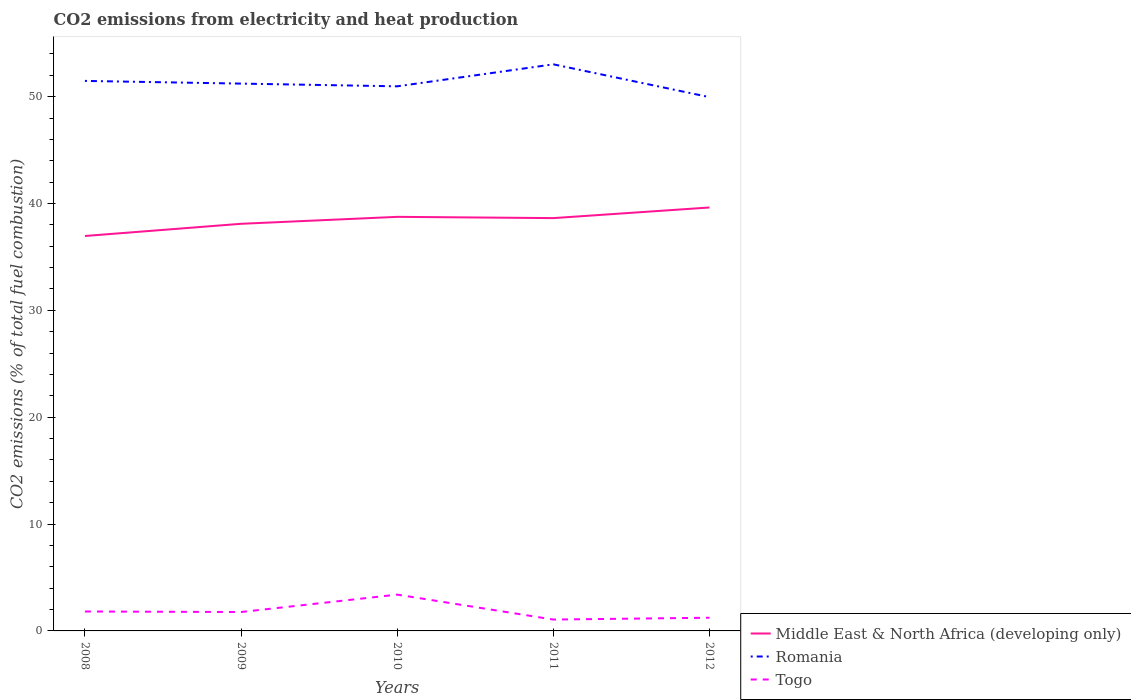Does the line corresponding to Romania intersect with the line corresponding to Togo?
Your answer should be very brief. No. Is the number of lines equal to the number of legend labels?
Keep it short and to the point. Yes. Across all years, what is the maximum amount of CO2 emitted in Romania?
Your response must be concise. 49.96. What is the total amount of CO2 emitted in Middle East & North Africa (developing only) in the graph?
Keep it short and to the point. -1.14. What is the difference between the highest and the second highest amount of CO2 emitted in Middle East & North Africa (developing only)?
Provide a short and direct response. 2.67. How many lines are there?
Make the answer very short. 3. Are the values on the major ticks of Y-axis written in scientific E-notation?
Ensure brevity in your answer.  No. What is the title of the graph?
Make the answer very short. CO2 emissions from electricity and heat production. Does "Small states" appear as one of the legend labels in the graph?
Your response must be concise. No. What is the label or title of the Y-axis?
Your answer should be compact. CO2 emissions (% of total fuel combustion). What is the CO2 emissions (% of total fuel combustion) in Middle East & North Africa (developing only) in 2008?
Your answer should be compact. 36.96. What is the CO2 emissions (% of total fuel combustion) in Romania in 2008?
Give a very brief answer. 51.47. What is the CO2 emissions (% of total fuel combustion) in Togo in 2008?
Provide a succinct answer. 1.82. What is the CO2 emissions (% of total fuel combustion) in Middle East & North Africa (developing only) in 2009?
Give a very brief answer. 38.1. What is the CO2 emissions (% of total fuel combustion) of Romania in 2009?
Ensure brevity in your answer.  51.22. What is the CO2 emissions (% of total fuel combustion) of Togo in 2009?
Give a very brief answer. 1.77. What is the CO2 emissions (% of total fuel combustion) in Middle East & North Africa (developing only) in 2010?
Your answer should be very brief. 38.75. What is the CO2 emissions (% of total fuel combustion) in Romania in 2010?
Offer a very short reply. 50.97. What is the CO2 emissions (% of total fuel combustion) of Togo in 2010?
Your answer should be very brief. 3.4. What is the CO2 emissions (% of total fuel combustion) of Middle East & North Africa (developing only) in 2011?
Provide a succinct answer. 38.63. What is the CO2 emissions (% of total fuel combustion) in Romania in 2011?
Give a very brief answer. 53.03. What is the CO2 emissions (% of total fuel combustion) of Togo in 2011?
Keep it short and to the point. 1.06. What is the CO2 emissions (% of total fuel combustion) of Middle East & North Africa (developing only) in 2012?
Offer a very short reply. 39.63. What is the CO2 emissions (% of total fuel combustion) of Romania in 2012?
Offer a terse response. 49.96. What is the CO2 emissions (% of total fuel combustion) of Togo in 2012?
Your response must be concise. 1.23. Across all years, what is the maximum CO2 emissions (% of total fuel combustion) in Middle East & North Africa (developing only)?
Provide a succinct answer. 39.63. Across all years, what is the maximum CO2 emissions (% of total fuel combustion) in Romania?
Give a very brief answer. 53.03. Across all years, what is the maximum CO2 emissions (% of total fuel combustion) of Togo?
Ensure brevity in your answer.  3.4. Across all years, what is the minimum CO2 emissions (% of total fuel combustion) in Middle East & North Africa (developing only)?
Provide a succinct answer. 36.96. Across all years, what is the minimum CO2 emissions (% of total fuel combustion) of Romania?
Your response must be concise. 49.96. Across all years, what is the minimum CO2 emissions (% of total fuel combustion) of Togo?
Keep it short and to the point. 1.06. What is the total CO2 emissions (% of total fuel combustion) of Middle East & North Africa (developing only) in the graph?
Your response must be concise. 192.08. What is the total CO2 emissions (% of total fuel combustion) in Romania in the graph?
Keep it short and to the point. 256.65. What is the total CO2 emissions (% of total fuel combustion) of Togo in the graph?
Keep it short and to the point. 9.28. What is the difference between the CO2 emissions (% of total fuel combustion) in Middle East & North Africa (developing only) in 2008 and that in 2009?
Keep it short and to the point. -1.14. What is the difference between the CO2 emissions (% of total fuel combustion) in Romania in 2008 and that in 2009?
Give a very brief answer. 0.25. What is the difference between the CO2 emissions (% of total fuel combustion) in Togo in 2008 and that in 2009?
Keep it short and to the point. 0.05. What is the difference between the CO2 emissions (% of total fuel combustion) of Middle East & North Africa (developing only) in 2008 and that in 2010?
Your answer should be compact. -1.79. What is the difference between the CO2 emissions (% of total fuel combustion) in Romania in 2008 and that in 2010?
Make the answer very short. 0.51. What is the difference between the CO2 emissions (% of total fuel combustion) of Togo in 2008 and that in 2010?
Your answer should be very brief. -1.58. What is the difference between the CO2 emissions (% of total fuel combustion) of Middle East & North Africa (developing only) in 2008 and that in 2011?
Keep it short and to the point. -1.67. What is the difference between the CO2 emissions (% of total fuel combustion) in Romania in 2008 and that in 2011?
Keep it short and to the point. -1.55. What is the difference between the CO2 emissions (% of total fuel combustion) in Togo in 2008 and that in 2011?
Give a very brief answer. 0.75. What is the difference between the CO2 emissions (% of total fuel combustion) in Middle East & North Africa (developing only) in 2008 and that in 2012?
Make the answer very short. -2.67. What is the difference between the CO2 emissions (% of total fuel combustion) of Romania in 2008 and that in 2012?
Offer a very short reply. 1.52. What is the difference between the CO2 emissions (% of total fuel combustion) of Togo in 2008 and that in 2012?
Ensure brevity in your answer.  0.58. What is the difference between the CO2 emissions (% of total fuel combustion) of Middle East & North Africa (developing only) in 2009 and that in 2010?
Your response must be concise. -0.65. What is the difference between the CO2 emissions (% of total fuel combustion) in Romania in 2009 and that in 2010?
Offer a terse response. 0.25. What is the difference between the CO2 emissions (% of total fuel combustion) in Togo in 2009 and that in 2010?
Offer a very short reply. -1.63. What is the difference between the CO2 emissions (% of total fuel combustion) in Middle East & North Africa (developing only) in 2009 and that in 2011?
Ensure brevity in your answer.  -0.53. What is the difference between the CO2 emissions (% of total fuel combustion) of Romania in 2009 and that in 2011?
Keep it short and to the point. -1.8. What is the difference between the CO2 emissions (% of total fuel combustion) of Togo in 2009 and that in 2011?
Make the answer very short. 0.71. What is the difference between the CO2 emissions (% of total fuel combustion) in Middle East & North Africa (developing only) in 2009 and that in 2012?
Offer a terse response. -1.53. What is the difference between the CO2 emissions (% of total fuel combustion) in Romania in 2009 and that in 2012?
Provide a succinct answer. 1.27. What is the difference between the CO2 emissions (% of total fuel combustion) in Togo in 2009 and that in 2012?
Provide a short and direct response. 0.54. What is the difference between the CO2 emissions (% of total fuel combustion) of Middle East & North Africa (developing only) in 2010 and that in 2011?
Offer a very short reply. 0.12. What is the difference between the CO2 emissions (% of total fuel combustion) in Romania in 2010 and that in 2011?
Make the answer very short. -2.06. What is the difference between the CO2 emissions (% of total fuel combustion) of Togo in 2010 and that in 2011?
Keep it short and to the point. 2.33. What is the difference between the CO2 emissions (% of total fuel combustion) in Middle East & North Africa (developing only) in 2010 and that in 2012?
Your response must be concise. -0.88. What is the difference between the CO2 emissions (% of total fuel combustion) in Romania in 2010 and that in 2012?
Offer a terse response. 1.01. What is the difference between the CO2 emissions (% of total fuel combustion) of Togo in 2010 and that in 2012?
Provide a succinct answer. 2.16. What is the difference between the CO2 emissions (% of total fuel combustion) in Middle East & North Africa (developing only) in 2011 and that in 2012?
Keep it short and to the point. -0.99. What is the difference between the CO2 emissions (% of total fuel combustion) of Romania in 2011 and that in 2012?
Offer a very short reply. 3.07. What is the difference between the CO2 emissions (% of total fuel combustion) of Togo in 2011 and that in 2012?
Your answer should be compact. -0.17. What is the difference between the CO2 emissions (% of total fuel combustion) in Middle East & North Africa (developing only) in 2008 and the CO2 emissions (% of total fuel combustion) in Romania in 2009?
Ensure brevity in your answer.  -14.26. What is the difference between the CO2 emissions (% of total fuel combustion) of Middle East & North Africa (developing only) in 2008 and the CO2 emissions (% of total fuel combustion) of Togo in 2009?
Your answer should be compact. 35.19. What is the difference between the CO2 emissions (% of total fuel combustion) in Romania in 2008 and the CO2 emissions (% of total fuel combustion) in Togo in 2009?
Your answer should be compact. 49.7. What is the difference between the CO2 emissions (% of total fuel combustion) in Middle East & North Africa (developing only) in 2008 and the CO2 emissions (% of total fuel combustion) in Romania in 2010?
Your response must be concise. -14.01. What is the difference between the CO2 emissions (% of total fuel combustion) of Middle East & North Africa (developing only) in 2008 and the CO2 emissions (% of total fuel combustion) of Togo in 2010?
Your answer should be compact. 33.56. What is the difference between the CO2 emissions (% of total fuel combustion) in Romania in 2008 and the CO2 emissions (% of total fuel combustion) in Togo in 2010?
Keep it short and to the point. 48.08. What is the difference between the CO2 emissions (% of total fuel combustion) of Middle East & North Africa (developing only) in 2008 and the CO2 emissions (% of total fuel combustion) of Romania in 2011?
Your response must be concise. -16.06. What is the difference between the CO2 emissions (% of total fuel combustion) in Middle East & North Africa (developing only) in 2008 and the CO2 emissions (% of total fuel combustion) in Togo in 2011?
Provide a succinct answer. 35.9. What is the difference between the CO2 emissions (% of total fuel combustion) in Romania in 2008 and the CO2 emissions (% of total fuel combustion) in Togo in 2011?
Your answer should be very brief. 50.41. What is the difference between the CO2 emissions (% of total fuel combustion) in Middle East & North Africa (developing only) in 2008 and the CO2 emissions (% of total fuel combustion) in Romania in 2012?
Offer a very short reply. -12.99. What is the difference between the CO2 emissions (% of total fuel combustion) in Middle East & North Africa (developing only) in 2008 and the CO2 emissions (% of total fuel combustion) in Togo in 2012?
Your response must be concise. 35.73. What is the difference between the CO2 emissions (% of total fuel combustion) of Romania in 2008 and the CO2 emissions (% of total fuel combustion) of Togo in 2012?
Give a very brief answer. 50.24. What is the difference between the CO2 emissions (% of total fuel combustion) of Middle East & North Africa (developing only) in 2009 and the CO2 emissions (% of total fuel combustion) of Romania in 2010?
Provide a succinct answer. -12.87. What is the difference between the CO2 emissions (% of total fuel combustion) of Middle East & North Africa (developing only) in 2009 and the CO2 emissions (% of total fuel combustion) of Togo in 2010?
Provide a short and direct response. 34.7. What is the difference between the CO2 emissions (% of total fuel combustion) in Romania in 2009 and the CO2 emissions (% of total fuel combustion) in Togo in 2010?
Your response must be concise. 47.82. What is the difference between the CO2 emissions (% of total fuel combustion) in Middle East & North Africa (developing only) in 2009 and the CO2 emissions (% of total fuel combustion) in Romania in 2011?
Provide a short and direct response. -14.92. What is the difference between the CO2 emissions (% of total fuel combustion) of Middle East & North Africa (developing only) in 2009 and the CO2 emissions (% of total fuel combustion) of Togo in 2011?
Make the answer very short. 37.04. What is the difference between the CO2 emissions (% of total fuel combustion) of Romania in 2009 and the CO2 emissions (% of total fuel combustion) of Togo in 2011?
Make the answer very short. 50.16. What is the difference between the CO2 emissions (% of total fuel combustion) in Middle East & North Africa (developing only) in 2009 and the CO2 emissions (% of total fuel combustion) in Romania in 2012?
Provide a succinct answer. -11.85. What is the difference between the CO2 emissions (% of total fuel combustion) in Middle East & North Africa (developing only) in 2009 and the CO2 emissions (% of total fuel combustion) in Togo in 2012?
Make the answer very short. 36.87. What is the difference between the CO2 emissions (% of total fuel combustion) in Romania in 2009 and the CO2 emissions (% of total fuel combustion) in Togo in 2012?
Offer a terse response. 49.99. What is the difference between the CO2 emissions (% of total fuel combustion) in Middle East & North Africa (developing only) in 2010 and the CO2 emissions (% of total fuel combustion) in Romania in 2011?
Provide a short and direct response. -14.27. What is the difference between the CO2 emissions (% of total fuel combustion) of Middle East & North Africa (developing only) in 2010 and the CO2 emissions (% of total fuel combustion) of Togo in 2011?
Keep it short and to the point. 37.69. What is the difference between the CO2 emissions (% of total fuel combustion) in Romania in 2010 and the CO2 emissions (% of total fuel combustion) in Togo in 2011?
Make the answer very short. 49.9. What is the difference between the CO2 emissions (% of total fuel combustion) of Middle East & North Africa (developing only) in 2010 and the CO2 emissions (% of total fuel combustion) of Romania in 2012?
Ensure brevity in your answer.  -11.2. What is the difference between the CO2 emissions (% of total fuel combustion) in Middle East & North Africa (developing only) in 2010 and the CO2 emissions (% of total fuel combustion) in Togo in 2012?
Your answer should be compact. 37.52. What is the difference between the CO2 emissions (% of total fuel combustion) of Romania in 2010 and the CO2 emissions (% of total fuel combustion) of Togo in 2012?
Offer a very short reply. 49.73. What is the difference between the CO2 emissions (% of total fuel combustion) of Middle East & North Africa (developing only) in 2011 and the CO2 emissions (% of total fuel combustion) of Romania in 2012?
Ensure brevity in your answer.  -11.32. What is the difference between the CO2 emissions (% of total fuel combustion) of Middle East & North Africa (developing only) in 2011 and the CO2 emissions (% of total fuel combustion) of Togo in 2012?
Your response must be concise. 37.4. What is the difference between the CO2 emissions (% of total fuel combustion) in Romania in 2011 and the CO2 emissions (% of total fuel combustion) in Togo in 2012?
Your answer should be very brief. 51.79. What is the average CO2 emissions (% of total fuel combustion) in Middle East & North Africa (developing only) per year?
Make the answer very short. 38.42. What is the average CO2 emissions (% of total fuel combustion) in Romania per year?
Offer a very short reply. 51.33. What is the average CO2 emissions (% of total fuel combustion) in Togo per year?
Make the answer very short. 1.86. In the year 2008, what is the difference between the CO2 emissions (% of total fuel combustion) in Middle East & North Africa (developing only) and CO2 emissions (% of total fuel combustion) in Romania?
Your answer should be compact. -14.51. In the year 2008, what is the difference between the CO2 emissions (% of total fuel combustion) of Middle East & North Africa (developing only) and CO2 emissions (% of total fuel combustion) of Togo?
Keep it short and to the point. 35.14. In the year 2008, what is the difference between the CO2 emissions (% of total fuel combustion) in Romania and CO2 emissions (% of total fuel combustion) in Togo?
Provide a succinct answer. 49.66. In the year 2009, what is the difference between the CO2 emissions (% of total fuel combustion) of Middle East & North Africa (developing only) and CO2 emissions (% of total fuel combustion) of Romania?
Offer a very short reply. -13.12. In the year 2009, what is the difference between the CO2 emissions (% of total fuel combustion) in Middle East & North Africa (developing only) and CO2 emissions (% of total fuel combustion) in Togo?
Offer a very short reply. 36.33. In the year 2009, what is the difference between the CO2 emissions (% of total fuel combustion) in Romania and CO2 emissions (% of total fuel combustion) in Togo?
Offer a very short reply. 49.45. In the year 2010, what is the difference between the CO2 emissions (% of total fuel combustion) of Middle East & North Africa (developing only) and CO2 emissions (% of total fuel combustion) of Romania?
Provide a short and direct response. -12.22. In the year 2010, what is the difference between the CO2 emissions (% of total fuel combustion) of Middle East & North Africa (developing only) and CO2 emissions (% of total fuel combustion) of Togo?
Provide a succinct answer. 35.35. In the year 2010, what is the difference between the CO2 emissions (% of total fuel combustion) of Romania and CO2 emissions (% of total fuel combustion) of Togo?
Offer a very short reply. 47.57. In the year 2011, what is the difference between the CO2 emissions (% of total fuel combustion) of Middle East & North Africa (developing only) and CO2 emissions (% of total fuel combustion) of Romania?
Your answer should be compact. -14.39. In the year 2011, what is the difference between the CO2 emissions (% of total fuel combustion) of Middle East & North Africa (developing only) and CO2 emissions (% of total fuel combustion) of Togo?
Provide a short and direct response. 37.57. In the year 2011, what is the difference between the CO2 emissions (% of total fuel combustion) of Romania and CO2 emissions (% of total fuel combustion) of Togo?
Your response must be concise. 51.96. In the year 2012, what is the difference between the CO2 emissions (% of total fuel combustion) of Middle East & North Africa (developing only) and CO2 emissions (% of total fuel combustion) of Romania?
Provide a short and direct response. -10.33. In the year 2012, what is the difference between the CO2 emissions (% of total fuel combustion) of Middle East & North Africa (developing only) and CO2 emissions (% of total fuel combustion) of Togo?
Your response must be concise. 38.39. In the year 2012, what is the difference between the CO2 emissions (% of total fuel combustion) in Romania and CO2 emissions (% of total fuel combustion) in Togo?
Make the answer very short. 48.72. What is the ratio of the CO2 emissions (% of total fuel combustion) of Middle East & North Africa (developing only) in 2008 to that in 2009?
Offer a very short reply. 0.97. What is the ratio of the CO2 emissions (% of total fuel combustion) in Romania in 2008 to that in 2009?
Provide a succinct answer. 1. What is the ratio of the CO2 emissions (% of total fuel combustion) of Togo in 2008 to that in 2009?
Provide a short and direct response. 1.03. What is the ratio of the CO2 emissions (% of total fuel combustion) in Middle East & North Africa (developing only) in 2008 to that in 2010?
Give a very brief answer. 0.95. What is the ratio of the CO2 emissions (% of total fuel combustion) of Romania in 2008 to that in 2010?
Your answer should be compact. 1.01. What is the ratio of the CO2 emissions (% of total fuel combustion) in Togo in 2008 to that in 2010?
Your answer should be very brief. 0.54. What is the ratio of the CO2 emissions (% of total fuel combustion) of Middle East & North Africa (developing only) in 2008 to that in 2011?
Give a very brief answer. 0.96. What is the ratio of the CO2 emissions (% of total fuel combustion) in Romania in 2008 to that in 2011?
Make the answer very short. 0.97. What is the ratio of the CO2 emissions (% of total fuel combustion) of Togo in 2008 to that in 2011?
Your answer should be very brief. 1.71. What is the ratio of the CO2 emissions (% of total fuel combustion) in Middle East & North Africa (developing only) in 2008 to that in 2012?
Provide a succinct answer. 0.93. What is the ratio of the CO2 emissions (% of total fuel combustion) in Romania in 2008 to that in 2012?
Provide a short and direct response. 1.03. What is the ratio of the CO2 emissions (% of total fuel combustion) of Togo in 2008 to that in 2012?
Your response must be concise. 1.47. What is the ratio of the CO2 emissions (% of total fuel combustion) of Middle East & North Africa (developing only) in 2009 to that in 2010?
Offer a very short reply. 0.98. What is the ratio of the CO2 emissions (% of total fuel combustion) of Togo in 2009 to that in 2010?
Offer a very short reply. 0.52. What is the ratio of the CO2 emissions (% of total fuel combustion) in Middle East & North Africa (developing only) in 2009 to that in 2011?
Your answer should be very brief. 0.99. What is the ratio of the CO2 emissions (% of total fuel combustion) in Togo in 2009 to that in 2011?
Your answer should be compact. 1.66. What is the ratio of the CO2 emissions (% of total fuel combustion) in Middle East & North Africa (developing only) in 2009 to that in 2012?
Ensure brevity in your answer.  0.96. What is the ratio of the CO2 emissions (% of total fuel combustion) of Romania in 2009 to that in 2012?
Your answer should be very brief. 1.03. What is the ratio of the CO2 emissions (% of total fuel combustion) of Togo in 2009 to that in 2012?
Your answer should be very brief. 1.43. What is the ratio of the CO2 emissions (% of total fuel combustion) in Middle East & North Africa (developing only) in 2010 to that in 2011?
Make the answer very short. 1. What is the ratio of the CO2 emissions (% of total fuel combustion) of Romania in 2010 to that in 2011?
Keep it short and to the point. 0.96. What is the ratio of the CO2 emissions (% of total fuel combustion) of Togo in 2010 to that in 2011?
Your answer should be compact. 3.19. What is the ratio of the CO2 emissions (% of total fuel combustion) of Middle East & North Africa (developing only) in 2010 to that in 2012?
Keep it short and to the point. 0.98. What is the ratio of the CO2 emissions (% of total fuel combustion) of Romania in 2010 to that in 2012?
Make the answer very short. 1.02. What is the ratio of the CO2 emissions (% of total fuel combustion) of Togo in 2010 to that in 2012?
Give a very brief answer. 2.75. What is the ratio of the CO2 emissions (% of total fuel combustion) in Middle East & North Africa (developing only) in 2011 to that in 2012?
Your answer should be very brief. 0.97. What is the ratio of the CO2 emissions (% of total fuel combustion) of Romania in 2011 to that in 2012?
Your answer should be compact. 1.06. What is the ratio of the CO2 emissions (% of total fuel combustion) of Togo in 2011 to that in 2012?
Provide a succinct answer. 0.86. What is the difference between the highest and the second highest CO2 emissions (% of total fuel combustion) in Middle East & North Africa (developing only)?
Your response must be concise. 0.88. What is the difference between the highest and the second highest CO2 emissions (% of total fuel combustion) of Romania?
Your response must be concise. 1.55. What is the difference between the highest and the second highest CO2 emissions (% of total fuel combustion) in Togo?
Make the answer very short. 1.58. What is the difference between the highest and the lowest CO2 emissions (% of total fuel combustion) of Middle East & North Africa (developing only)?
Your answer should be compact. 2.67. What is the difference between the highest and the lowest CO2 emissions (% of total fuel combustion) of Romania?
Your answer should be very brief. 3.07. What is the difference between the highest and the lowest CO2 emissions (% of total fuel combustion) of Togo?
Your answer should be very brief. 2.33. 